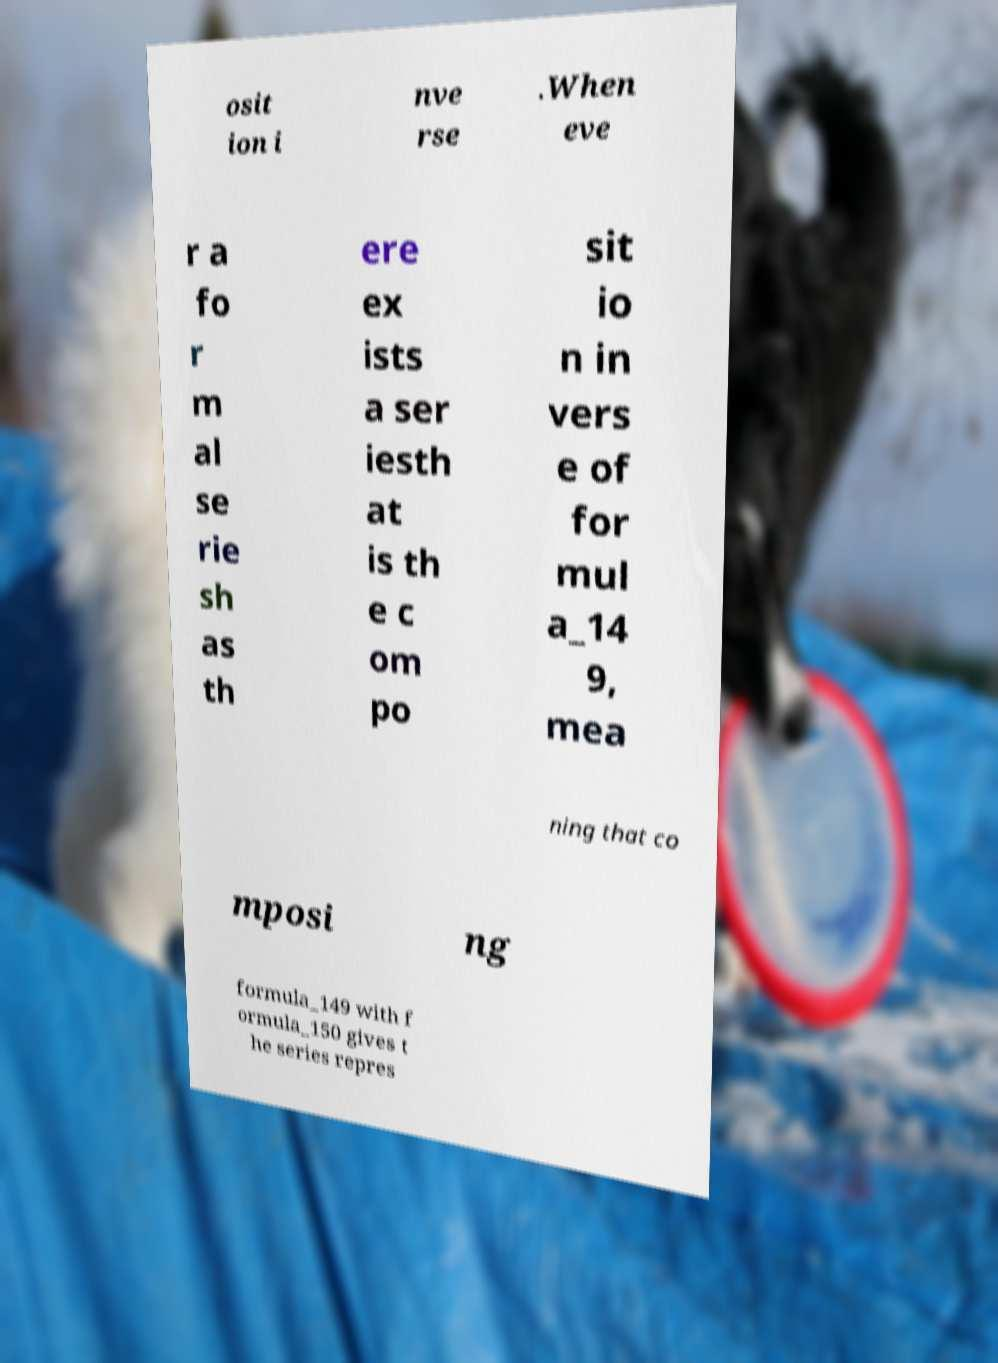Can you read and provide the text displayed in the image?This photo seems to have some interesting text. Can you extract and type it out for me? osit ion i nve rse .When eve r a fo r m al se rie sh as th ere ex ists a ser iesth at is th e c om po sit io n in vers e of for mul a_14 9, mea ning that co mposi ng formula_149 with f ormula_150 gives t he series repres 